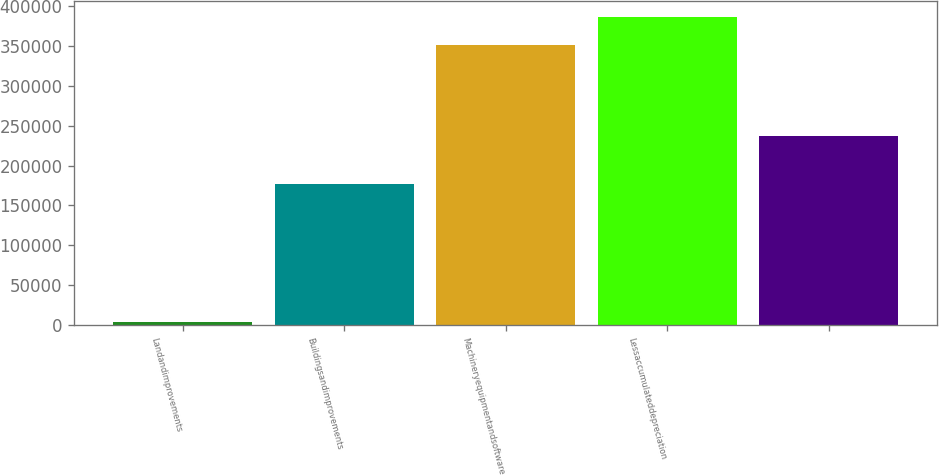Convert chart. <chart><loc_0><loc_0><loc_500><loc_500><bar_chart><fcel>Landandimprovements<fcel>Buildingsandimprovements<fcel>Machineryequipmentandsoftware<fcel>Lessaccumulateddepreciation<fcel>Unnamed: 4<nl><fcel>3954<fcel>176982<fcel>350471<fcel>386436<fcel>237527<nl></chart> 